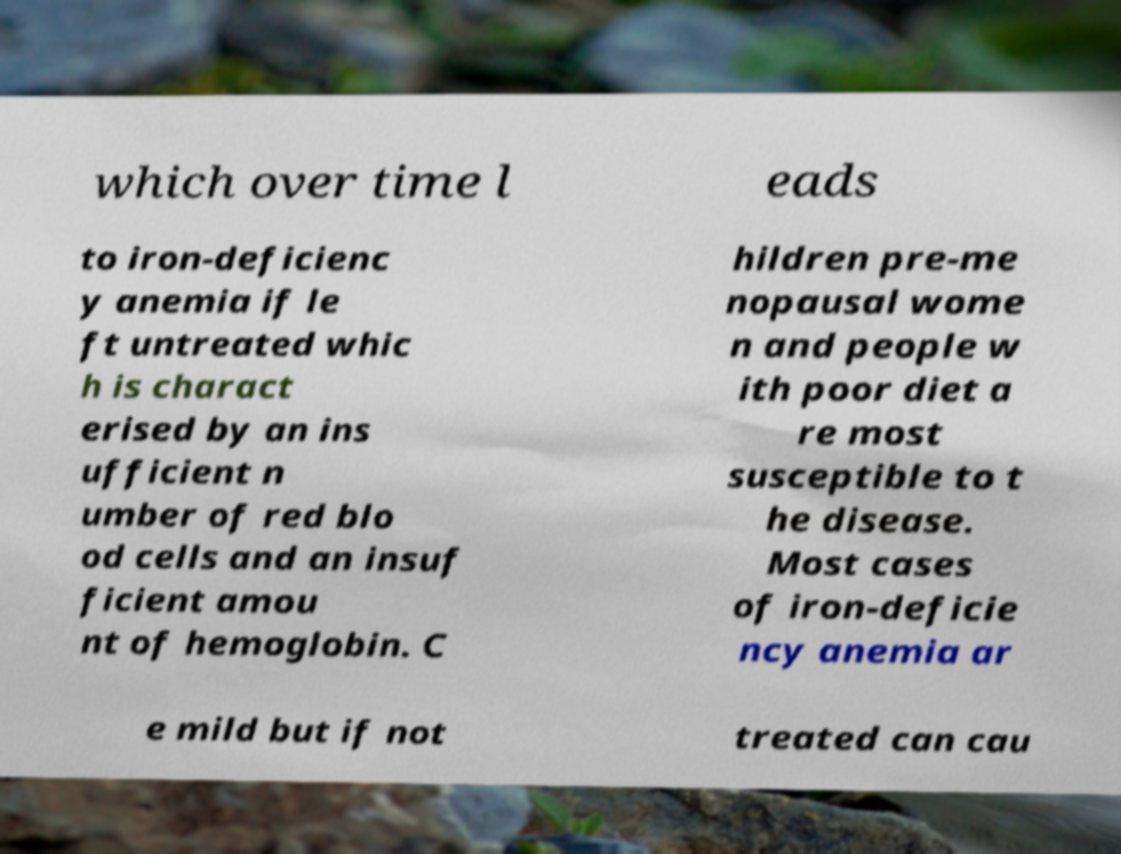Could you extract and type out the text from this image? which over time l eads to iron-deficienc y anemia if le ft untreated whic h is charact erised by an ins ufficient n umber of red blo od cells and an insuf ficient amou nt of hemoglobin. C hildren pre-me nopausal wome n and people w ith poor diet a re most susceptible to t he disease. Most cases of iron-deficie ncy anemia ar e mild but if not treated can cau 